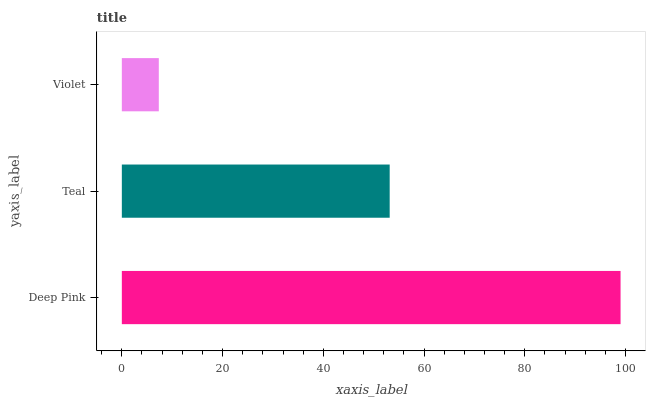Is Violet the minimum?
Answer yes or no. Yes. Is Deep Pink the maximum?
Answer yes or no. Yes. Is Teal the minimum?
Answer yes or no. No. Is Teal the maximum?
Answer yes or no. No. Is Deep Pink greater than Teal?
Answer yes or no. Yes. Is Teal less than Deep Pink?
Answer yes or no. Yes. Is Teal greater than Deep Pink?
Answer yes or no. No. Is Deep Pink less than Teal?
Answer yes or no. No. Is Teal the high median?
Answer yes or no. Yes. Is Teal the low median?
Answer yes or no. Yes. Is Violet the high median?
Answer yes or no. No. Is Violet the low median?
Answer yes or no. No. 